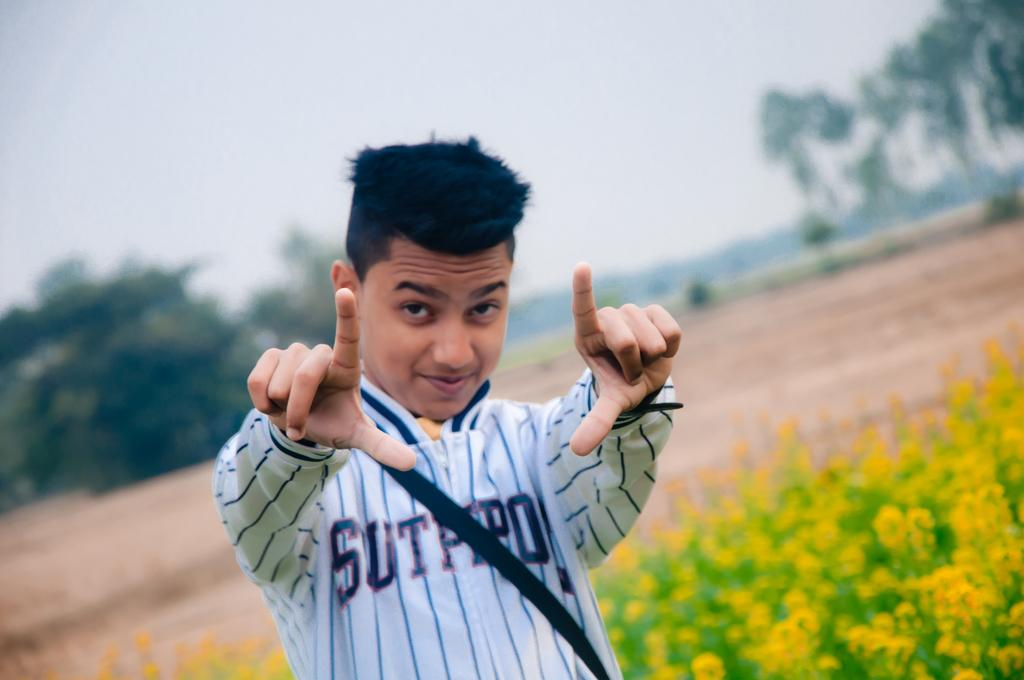Who is present in the image? There is a man in the image. What is the man wearing? The man is wearing clothes. What type of vegetation can be seen in the image? There are flower plants and trees in the image. What part of the natural environment is visible in the image? The sky is visible in the image. How would you describe the background of the image? The background of the image is blurred. Can you see a harbor or bridge in the image? No, there is no harbor or bridge present in the image. What type of crib is visible in the image? There is no crib present in the image. 